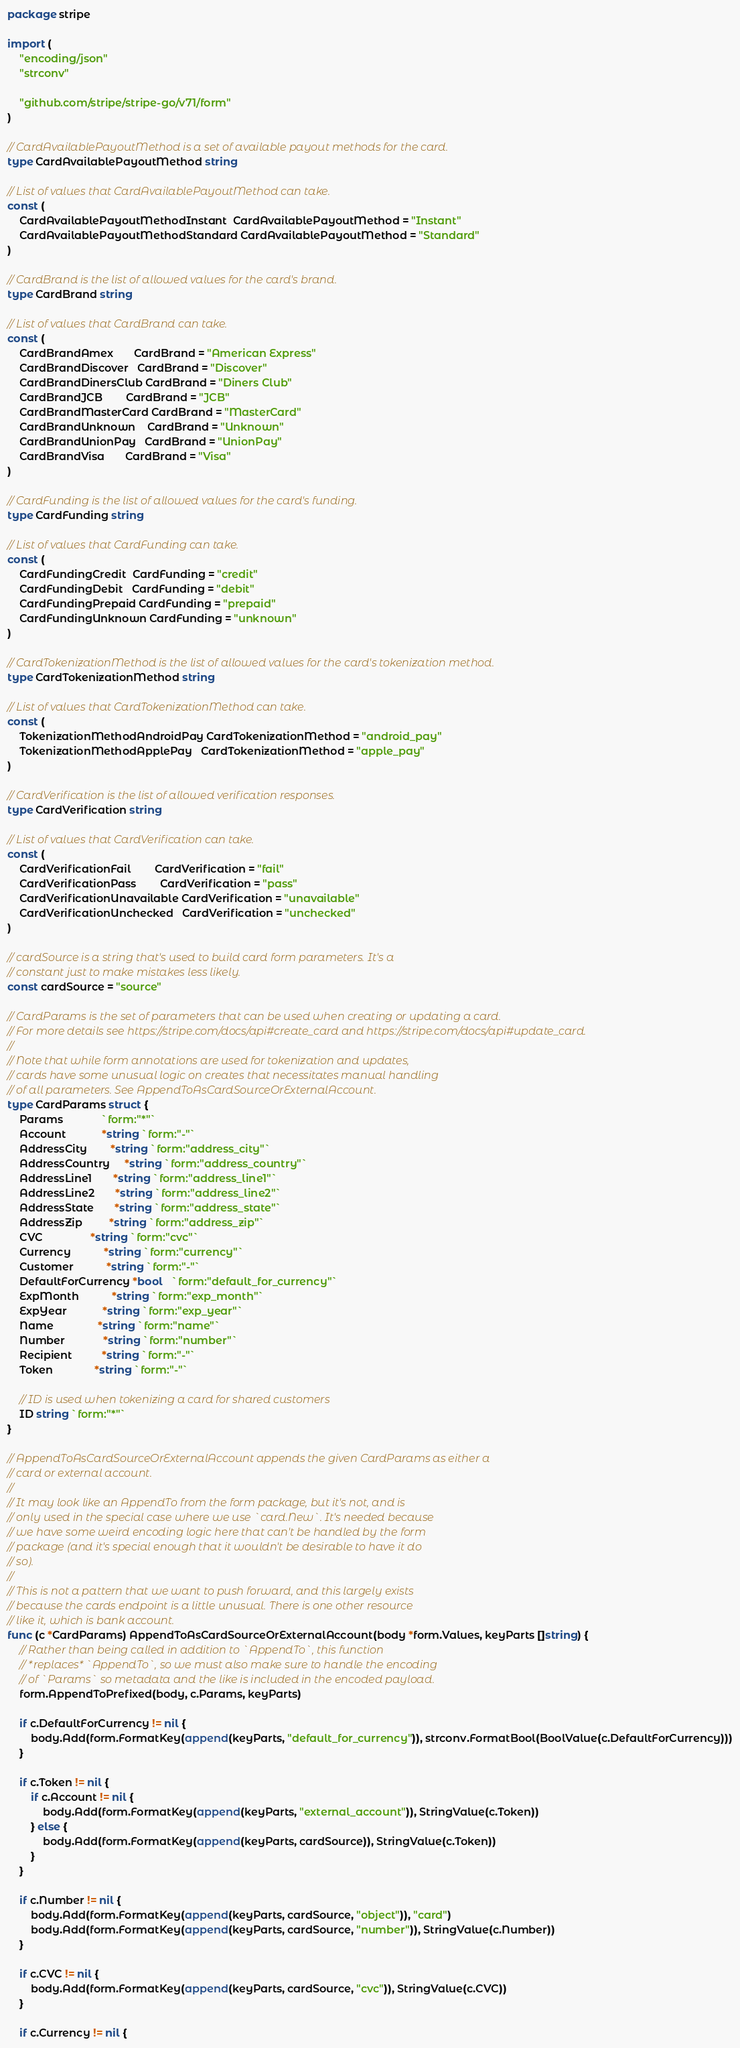Convert code to text. <code><loc_0><loc_0><loc_500><loc_500><_Go_>package stripe

import (
	"encoding/json"
	"strconv"

	"github.com/stripe/stripe-go/v71/form"
)

// CardAvailablePayoutMethod is a set of available payout methods for the card.
type CardAvailablePayoutMethod string

// List of values that CardAvailablePayoutMethod can take.
const (
	CardAvailablePayoutMethodInstant  CardAvailablePayoutMethod = "Instant"
	CardAvailablePayoutMethodStandard CardAvailablePayoutMethod = "Standard"
)

// CardBrand is the list of allowed values for the card's brand.
type CardBrand string

// List of values that CardBrand can take.
const (
	CardBrandAmex       CardBrand = "American Express"
	CardBrandDiscover   CardBrand = "Discover"
	CardBrandDinersClub CardBrand = "Diners Club"
	CardBrandJCB        CardBrand = "JCB"
	CardBrandMasterCard CardBrand = "MasterCard"
	CardBrandUnknown    CardBrand = "Unknown"
	CardBrandUnionPay   CardBrand = "UnionPay"
	CardBrandVisa       CardBrand = "Visa"
)

// CardFunding is the list of allowed values for the card's funding.
type CardFunding string

// List of values that CardFunding can take.
const (
	CardFundingCredit  CardFunding = "credit"
	CardFundingDebit   CardFunding = "debit"
	CardFundingPrepaid CardFunding = "prepaid"
	CardFundingUnknown CardFunding = "unknown"
)

// CardTokenizationMethod is the list of allowed values for the card's tokenization method.
type CardTokenizationMethod string

// List of values that CardTokenizationMethod can take.
const (
	TokenizationMethodAndroidPay CardTokenizationMethod = "android_pay"
	TokenizationMethodApplePay   CardTokenizationMethod = "apple_pay"
)

// CardVerification is the list of allowed verification responses.
type CardVerification string

// List of values that CardVerification can take.
const (
	CardVerificationFail        CardVerification = "fail"
	CardVerificationPass        CardVerification = "pass"
	CardVerificationUnavailable CardVerification = "unavailable"
	CardVerificationUnchecked   CardVerification = "unchecked"
)

// cardSource is a string that's used to build card form parameters. It's a
// constant just to make mistakes less likely.
const cardSource = "source"

// CardParams is the set of parameters that can be used when creating or updating a card.
// For more details see https://stripe.com/docs/api#create_card and https://stripe.com/docs/api#update_card.
//
// Note that while form annotations are used for tokenization and updates,
// cards have some unusual logic on creates that necessitates manual handling
// of all parameters. See AppendToAsCardSourceOrExternalAccount.
type CardParams struct {
	Params             `form:"*"`
	Account            *string `form:"-"`
	AddressCity        *string `form:"address_city"`
	AddressCountry     *string `form:"address_country"`
	AddressLine1       *string `form:"address_line1"`
	AddressLine2       *string `form:"address_line2"`
	AddressState       *string `form:"address_state"`
	AddressZip         *string `form:"address_zip"`
	CVC                *string `form:"cvc"`
	Currency           *string `form:"currency"`
	Customer           *string `form:"-"`
	DefaultForCurrency *bool   `form:"default_for_currency"`
	ExpMonth           *string `form:"exp_month"`
	ExpYear            *string `form:"exp_year"`
	Name               *string `form:"name"`
	Number             *string `form:"number"`
	Recipient          *string `form:"-"`
	Token              *string `form:"-"`

	// ID is used when tokenizing a card for shared customers
	ID string `form:"*"`
}

// AppendToAsCardSourceOrExternalAccount appends the given CardParams as either a
// card or external account.
//
// It may look like an AppendTo from the form package, but it's not, and is
// only used in the special case where we use `card.New`. It's needed because
// we have some weird encoding logic here that can't be handled by the form
// package (and it's special enough that it wouldn't be desirable to have it do
// so).
//
// This is not a pattern that we want to push forward, and this largely exists
// because the cards endpoint is a little unusual. There is one other resource
// like it, which is bank account.
func (c *CardParams) AppendToAsCardSourceOrExternalAccount(body *form.Values, keyParts []string) {
	// Rather than being called in addition to `AppendTo`, this function
	// *replaces* `AppendTo`, so we must also make sure to handle the encoding
	// of `Params` so metadata and the like is included in the encoded payload.
	form.AppendToPrefixed(body, c.Params, keyParts)

	if c.DefaultForCurrency != nil {
		body.Add(form.FormatKey(append(keyParts, "default_for_currency")), strconv.FormatBool(BoolValue(c.DefaultForCurrency)))
	}

	if c.Token != nil {
		if c.Account != nil {
			body.Add(form.FormatKey(append(keyParts, "external_account")), StringValue(c.Token))
		} else {
			body.Add(form.FormatKey(append(keyParts, cardSource)), StringValue(c.Token))
		}
	}

	if c.Number != nil {
		body.Add(form.FormatKey(append(keyParts, cardSource, "object")), "card")
		body.Add(form.FormatKey(append(keyParts, cardSource, "number")), StringValue(c.Number))
	}

	if c.CVC != nil {
		body.Add(form.FormatKey(append(keyParts, cardSource, "cvc")), StringValue(c.CVC))
	}

	if c.Currency != nil {</code> 